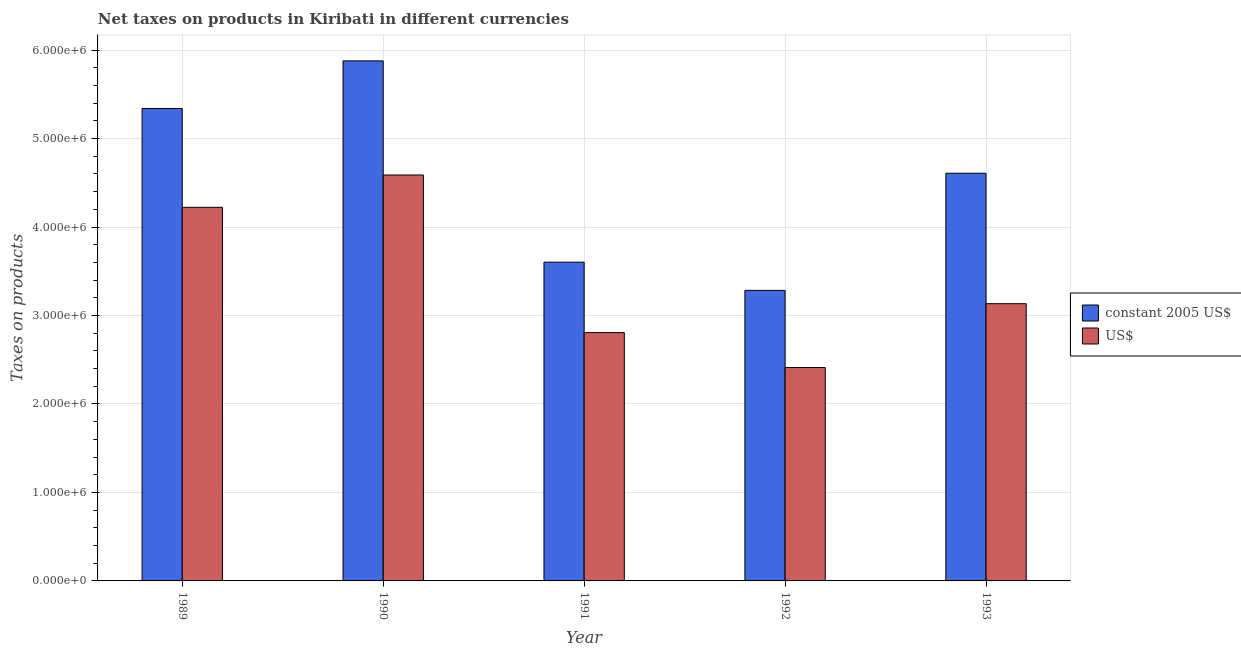How many different coloured bars are there?
Your answer should be very brief. 2. Are the number of bars per tick equal to the number of legend labels?
Offer a very short reply. Yes. Are the number of bars on each tick of the X-axis equal?
Your answer should be very brief. Yes. How many bars are there on the 1st tick from the left?
Provide a short and direct response. 2. How many bars are there on the 1st tick from the right?
Offer a very short reply. 2. In how many cases, is the number of bars for a given year not equal to the number of legend labels?
Keep it short and to the point. 0. What is the net taxes in us$ in 1992?
Your answer should be compact. 2.41e+06. Across all years, what is the maximum net taxes in constant 2005 us$?
Provide a short and direct response. 5.88e+06. Across all years, what is the minimum net taxes in us$?
Offer a terse response. 2.41e+06. In which year was the net taxes in constant 2005 us$ maximum?
Your answer should be very brief. 1990. In which year was the net taxes in us$ minimum?
Ensure brevity in your answer.  1992. What is the total net taxes in constant 2005 us$ in the graph?
Provide a succinct answer. 2.27e+07. What is the difference between the net taxes in us$ in 1989 and that in 1990?
Make the answer very short. -3.66e+05. What is the difference between the net taxes in constant 2005 us$ in 1990 and the net taxes in us$ in 1989?
Your answer should be very brief. 5.38e+05. What is the average net taxes in constant 2005 us$ per year?
Provide a short and direct response. 4.54e+06. In how many years, is the net taxes in constant 2005 us$ greater than 800000 units?
Offer a very short reply. 5. What is the ratio of the net taxes in constant 2005 us$ in 1989 to that in 1991?
Provide a short and direct response. 1.48. Is the net taxes in us$ in 1991 less than that in 1992?
Make the answer very short. No. What is the difference between the highest and the second highest net taxes in constant 2005 us$?
Make the answer very short. 5.38e+05. What is the difference between the highest and the lowest net taxes in us$?
Your answer should be very brief. 2.18e+06. Is the sum of the net taxes in us$ in 1991 and 1993 greater than the maximum net taxes in constant 2005 us$ across all years?
Ensure brevity in your answer.  Yes. What does the 1st bar from the left in 1993 represents?
Provide a succinct answer. Constant 2005 us$. What does the 2nd bar from the right in 1989 represents?
Offer a terse response. Constant 2005 us$. How many bars are there?
Provide a succinct answer. 10. How many years are there in the graph?
Offer a very short reply. 5. What is the difference between two consecutive major ticks on the Y-axis?
Make the answer very short. 1.00e+06. Where does the legend appear in the graph?
Offer a terse response. Center right. How many legend labels are there?
Offer a very short reply. 2. What is the title of the graph?
Keep it short and to the point. Net taxes on products in Kiribati in different currencies. Does "Primary education" appear as one of the legend labels in the graph?
Your response must be concise. No. What is the label or title of the X-axis?
Keep it short and to the point. Year. What is the label or title of the Y-axis?
Provide a succinct answer. Taxes on products. What is the Taxes on products of constant 2005 US$ in 1989?
Your answer should be compact. 5.34e+06. What is the Taxes on products in US$ in 1989?
Give a very brief answer. 4.22e+06. What is the Taxes on products in constant 2005 US$ in 1990?
Your answer should be very brief. 5.88e+06. What is the Taxes on products in US$ in 1990?
Your response must be concise. 4.59e+06. What is the Taxes on products of constant 2005 US$ in 1991?
Make the answer very short. 3.60e+06. What is the Taxes on products of US$ in 1991?
Provide a succinct answer. 2.81e+06. What is the Taxes on products in constant 2005 US$ in 1992?
Provide a short and direct response. 3.28e+06. What is the Taxes on products in US$ in 1992?
Your answer should be compact. 2.41e+06. What is the Taxes on products of constant 2005 US$ in 1993?
Provide a short and direct response. 4.61e+06. What is the Taxes on products of US$ in 1993?
Ensure brevity in your answer.  3.13e+06. Across all years, what is the maximum Taxes on products in constant 2005 US$?
Provide a short and direct response. 5.88e+06. Across all years, what is the maximum Taxes on products in US$?
Your answer should be compact. 4.59e+06. Across all years, what is the minimum Taxes on products of constant 2005 US$?
Your response must be concise. 3.28e+06. Across all years, what is the minimum Taxes on products in US$?
Your answer should be compact. 2.41e+06. What is the total Taxes on products in constant 2005 US$ in the graph?
Offer a very short reply. 2.27e+07. What is the total Taxes on products in US$ in the graph?
Your response must be concise. 1.72e+07. What is the difference between the Taxes on products of constant 2005 US$ in 1989 and that in 1990?
Offer a terse response. -5.38e+05. What is the difference between the Taxes on products of US$ in 1989 and that in 1990?
Give a very brief answer. -3.66e+05. What is the difference between the Taxes on products of constant 2005 US$ in 1989 and that in 1991?
Your answer should be compact. 1.74e+06. What is the difference between the Taxes on products of US$ in 1989 and that in 1991?
Give a very brief answer. 1.42e+06. What is the difference between the Taxes on products in constant 2005 US$ in 1989 and that in 1992?
Make the answer very short. 2.06e+06. What is the difference between the Taxes on products in US$ in 1989 and that in 1992?
Provide a short and direct response. 1.81e+06. What is the difference between the Taxes on products in constant 2005 US$ in 1989 and that in 1993?
Give a very brief answer. 7.32e+05. What is the difference between the Taxes on products in US$ in 1989 and that in 1993?
Keep it short and to the point. 1.09e+06. What is the difference between the Taxes on products of constant 2005 US$ in 1990 and that in 1991?
Give a very brief answer. 2.28e+06. What is the difference between the Taxes on products of US$ in 1990 and that in 1991?
Your answer should be very brief. 1.78e+06. What is the difference between the Taxes on products of constant 2005 US$ in 1990 and that in 1992?
Provide a short and direct response. 2.59e+06. What is the difference between the Taxes on products in US$ in 1990 and that in 1992?
Your answer should be compact. 2.18e+06. What is the difference between the Taxes on products of constant 2005 US$ in 1990 and that in 1993?
Ensure brevity in your answer.  1.27e+06. What is the difference between the Taxes on products in US$ in 1990 and that in 1993?
Provide a succinct answer. 1.45e+06. What is the difference between the Taxes on products in constant 2005 US$ in 1991 and that in 1992?
Offer a terse response. 3.19e+05. What is the difference between the Taxes on products in US$ in 1991 and that in 1992?
Keep it short and to the point. 3.95e+05. What is the difference between the Taxes on products in constant 2005 US$ in 1991 and that in 1993?
Make the answer very short. -1.00e+06. What is the difference between the Taxes on products in US$ in 1991 and that in 1993?
Ensure brevity in your answer.  -3.27e+05. What is the difference between the Taxes on products of constant 2005 US$ in 1992 and that in 1993?
Provide a short and direct response. -1.32e+06. What is the difference between the Taxes on products of US$ in 1992 and that in 1993?
Give a very brief answer. -7.22e+05. What is the difference between the Taxes on products in constant 2005 US$ in 1989 and the Taxes on products in US$ in 1990?
Your response must be concise. 7.52e+05. What is the difference between the Taxes on products in constant 2005 US$ in 1989 and the Taxes on products in US$ in 1991?
Ensure brevity in your answer.  2.53e+06. What is the difference between the Taxes on products of constant 2005 US$ in 1989 and the Taxes on products of US$ in 1992?
Your response must be concise. 2.93e+06. What is the difference between the Taxes on products in constant 2005 US$ in 1989 and the Taxes on products in US$ in 1993?
Offer a terse response. 2.21e+06. What is the difference between the Taxes on products of constant 2005 US$ in 1990 and the Taxes on products of US$ in 1991?
Offer a terse response. 3.07e+06. What is the difference between the Taxes on products of constant 2005 US$ in 1990 and the Taxes on products of US$ in 1992?
Offer a terse response. 3.47e+06. What is the difference between the Taxes on products of constant 2005 US$ in 1990 and the Taxes on products of US$ in 1993?
Your answer should be very brief. 2.74e+06. What is the difference between the Taxes on products of constant 2005 US$ in 1991 and the Taxes on products of US$ in 1992?
Provide a short and direct response. 1.19e+06. What is the difference between the Taxes on products of constant 2005 US$ in 1991 and the Taxes on products of US$ in 1993?
Your answer should be compact. 4.70e+05. What is the difference between the Taxes on products in constant 2005 US$ in 1992 and the Taxes on products in US$ in 1993?
Give a very brief answer. 1.51e+05. What is the average Taxes on products in constant 2005 US$ per year?
Your response must be concise. 4.54e+06. What is the average Taxes on products in US$ per year?
Offer a terse response. 3.43e+06. In the year 1989, what is the difference between the Taxes on products in constant 2005 US$ and Taxes on products in US$?
Give a very brief answer. 1.12e+06. In the year 1990, what is the difference between the Taxes on products of constant 2005 US$ and Taxes on products of US$?
Provide a short and direct response. 1.29e+06. In the year 1991, what is the difference between the Taxes on products of constant 2005 US$ and Taxes on products of US$?
Give a very brief answer. 7.96e+05. In the year 1992, what is the difference between the Taxes on products in constant 2005 US$ and Taxes on products in US$?
Offer a very short reply. 8.72e+05. In the year 1993, what is the difference between the Taxes on products of constant 2005 US$ and Taxes on products of US$?
Provide a short and direct response. 1.47e+06. What is the ratio of the Taxes on products in constant 2005 US$ in 1989 to that in 1990?
Provide a succinct answer. 0.91. What is the ratio of the Taxes on products of US$ in 1989 to that in 1990?
Ensure brevity in your answer.  0.92. What is the ratio of the Taxes on products of constant 2005 US$ in 1989 to that in 1991?
Ensure brevity in your answer.  1.48. What is the ratio of the Taxes on products of US$ in 1989 to that in 1991?
Give a very brief answer. 1.5. What is the ratio of the Taxes on products of constant 2005 US$ in 1989 to that in 1992?
Keep it short and to the point. 1.63. What is the ratio of the Taxes on products of US$ in 1989 to that in 1992?
Make the answer very short. 1.75. What is the ratio of the Taxes on products of constant 2005 US$ in 1989 to that in 1993?
Your response must be concise. 1.16. What is the ratio of the Taxes on products of US$ in 1989 to that in 1993?
Ensure brevity in your answer.  1.35. What is the ratio of the Taxes on products of constant 2005 US$ in 1990 to that in 1991?
Your response must be concise. 1.63. What is the ratio of the Taxes on products in US$ in 1990 to that in 1991?
Give a very brief answer. 1.63. What is the ratio of the Taxes on products of constant 2005 US$ in 1990 to that in 1992?
Offer a terse response. 1.79. What is the ratio of the Taxes on products in US$ in 1990 to that in 1992?
Provide a short and direct response. 1.9. What is the ratio of the Taxes on products in constant 2005 US$ in 1990 to that in 1993?
Your answer should be compact. 1.28. What is the ratio of the Taxes on products of US$ in 1990 to that in 1993?
Provide a succinct answer. 1.46. What is the ratio of the Taxes on products in constant 2005 US$ in 1991 to that in 1992?
Make the answer very short. 1.1. What is the ratio of the Taxes on products in US$ in 1991 to that in 1992?
Offer a terse response. 1.16. What is the ratio of the Taxes on products of constant 2005 US$ in 1991 to that in 1993?
Keep it short and to the point. 0.78. What is the ratio of the Taxes on products of US$ in 1991 to that in 1993?
Provide a succinct answer. 0.9. What is the ratio of the Taxes on products in constant 2005 US$ in 1992 to that in 1993?
Make the answer very short. 0.71. What is the ratio of the Taxes on products in US$ in 1992 to that in 1993?
Your response must be concise. 0.77. What is the difference between the highest and the second highest Taxes on products in constant 2005 US$?
Keep it short and to the point. 5.38e+05. What is the difference between the highest and the second highest Taxes on products in US$?
Give a very brief answer. 3.66e+05. What is the difference between the highest and the lowest Taxes on products of constant 2005 US$?
Offer a very short reply. 2.59e+06. What is the difference between the highest and the lowest Taxes on products of US$?
Ensure brevity in your answer.  2.18e+06. 